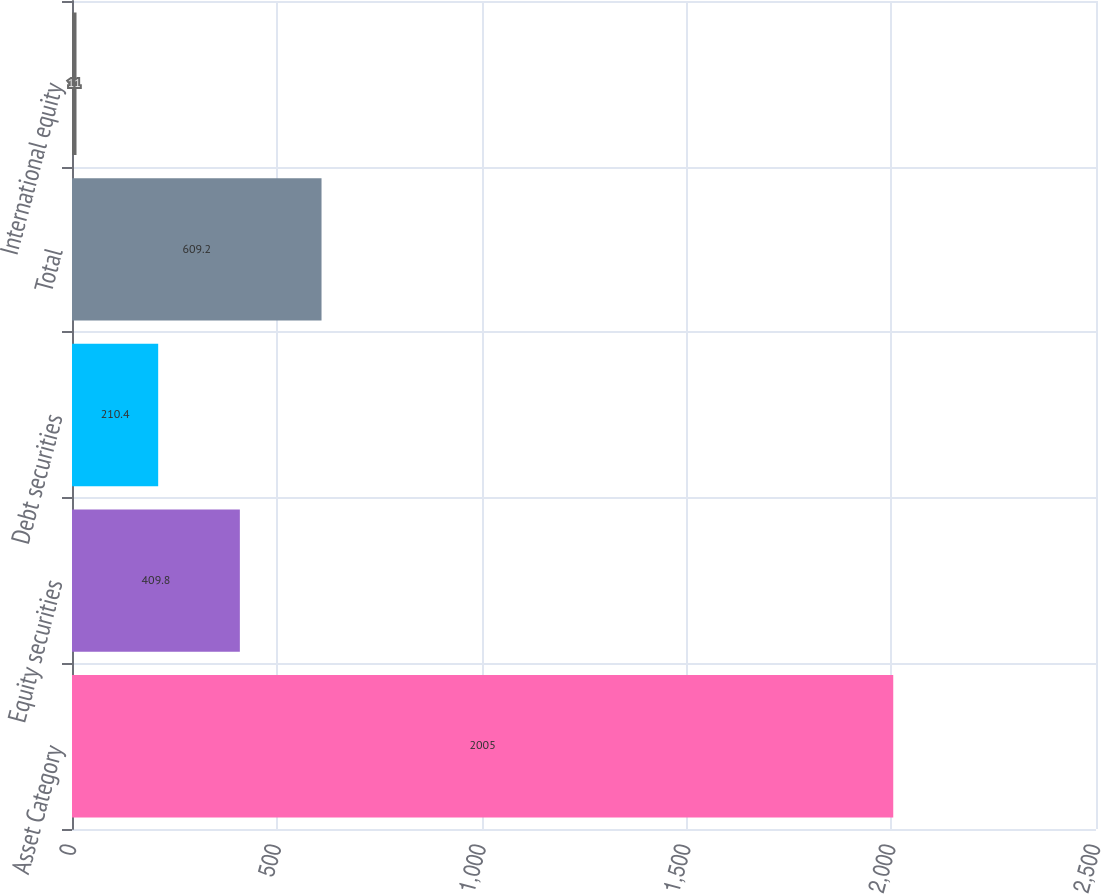Convert chart. <chart><loc_0><loc_0><loc_500><loc_500><bar_chart><fcel>Asset Category<fcel>Equity securities<fcel>Debt securities<fcel>Total<fcel>International equity<nl><fcel>2005<fcel>409.8<fcel>210.4<fcel>609.2<fcel>11<nl></chart> 